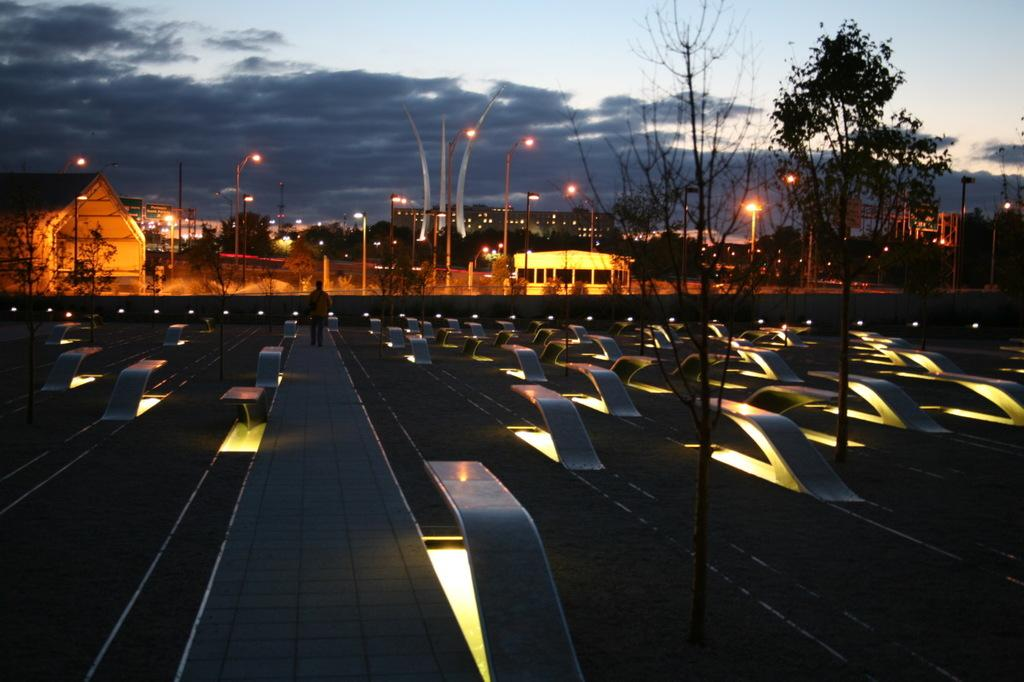What is the person in the image doing? There is a person walking in the image. What can be seen in the background of the image? There are plants, trees, and buildings in the backdrop of the image. What type of lighting is present in the image? There are street lights in the image. What else can be seen in the image? There are poles in the image. What is the condition of the sky in the image? The sky is clear in the image. Where is the throne located in the image? There is no throne present in the image. What type of cracker is being used by the army in the image? There is no army or cracker present in the image. 